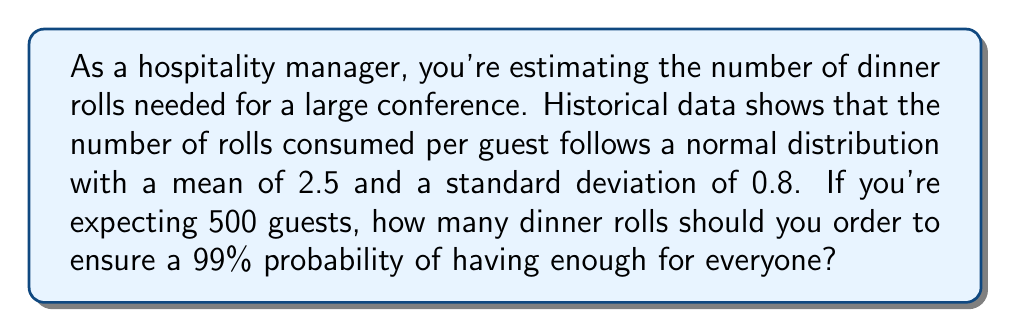Give your solution to this math problem. Let's approach this step-by-step:

1) We're dealing with a normal distribution where:
   $\mu = 2.5$ (mean)
   $\sigma = 0.8$ (standard deviation)
   $n = 500$ (number of guests)

2) We want to ensure a 99% probability of having enough rolls, which means we need to find the 99th percentile of the distribution for the total number of rolls.

3) For a normal distribution, the 99th percentile is approximately 2.33 standard deviations above the mean.

4) For a sum of independent normal variables, the mean and variance are additive. So for 500 guests:
   $\mu_{total} = 500 \times 2.5 = 1250$
   $\sigma_{total} = \sqrt{500} \times 0.8 = 17.89$

5) The 99th percentile for the total number of rolls is:
   $X = \mu_{total} + 2.33 \times \sigma_{total}$
   $X = 1250 + 2.33 \times 17.89 = 1291.68$

6) Since we can't order a fractional number of rolls, we round up to the nearest whole number.

Therefore, you should order 1292 dinner rolls to ensure a 99% probability of having enough for all guests.
Answer: 1292 dinner rolls 